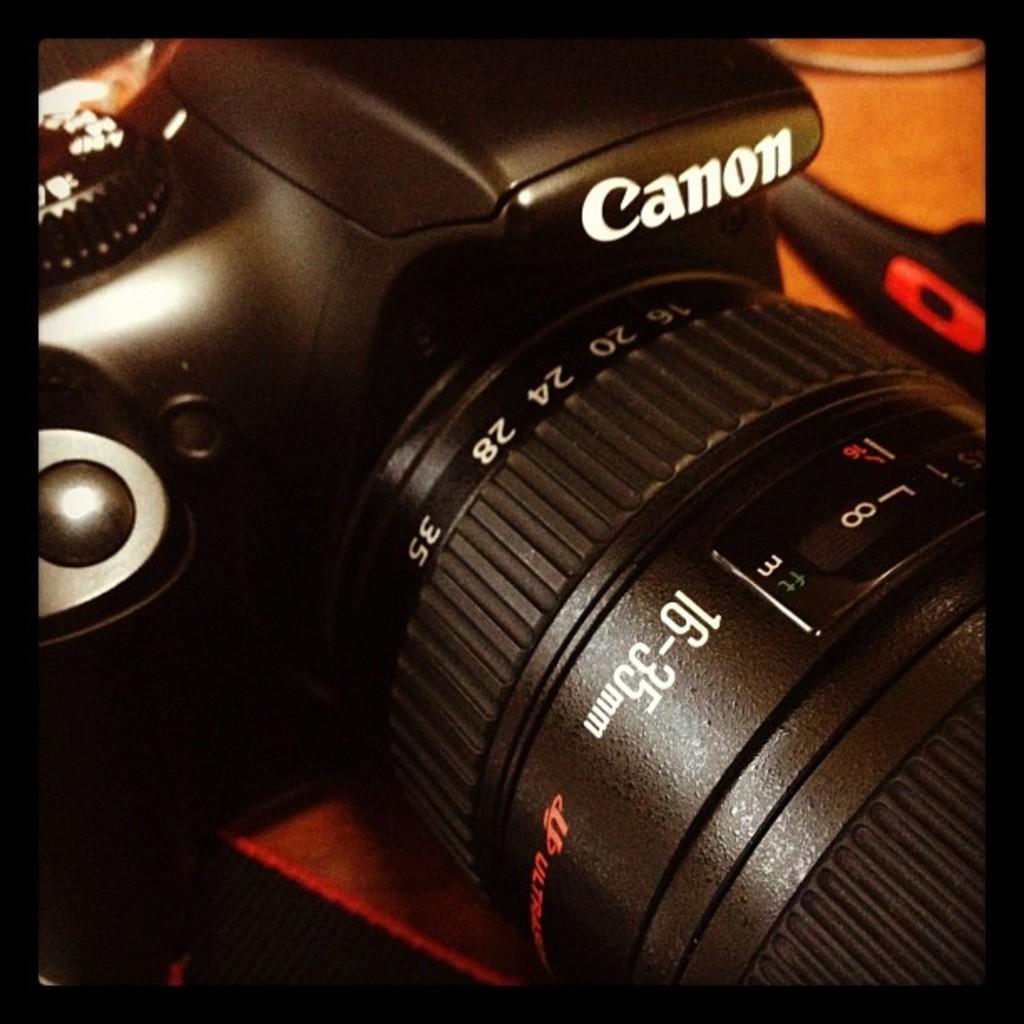Can you describe this image briefly? In this image in front there is a camera. Beside the camera there is some object. 